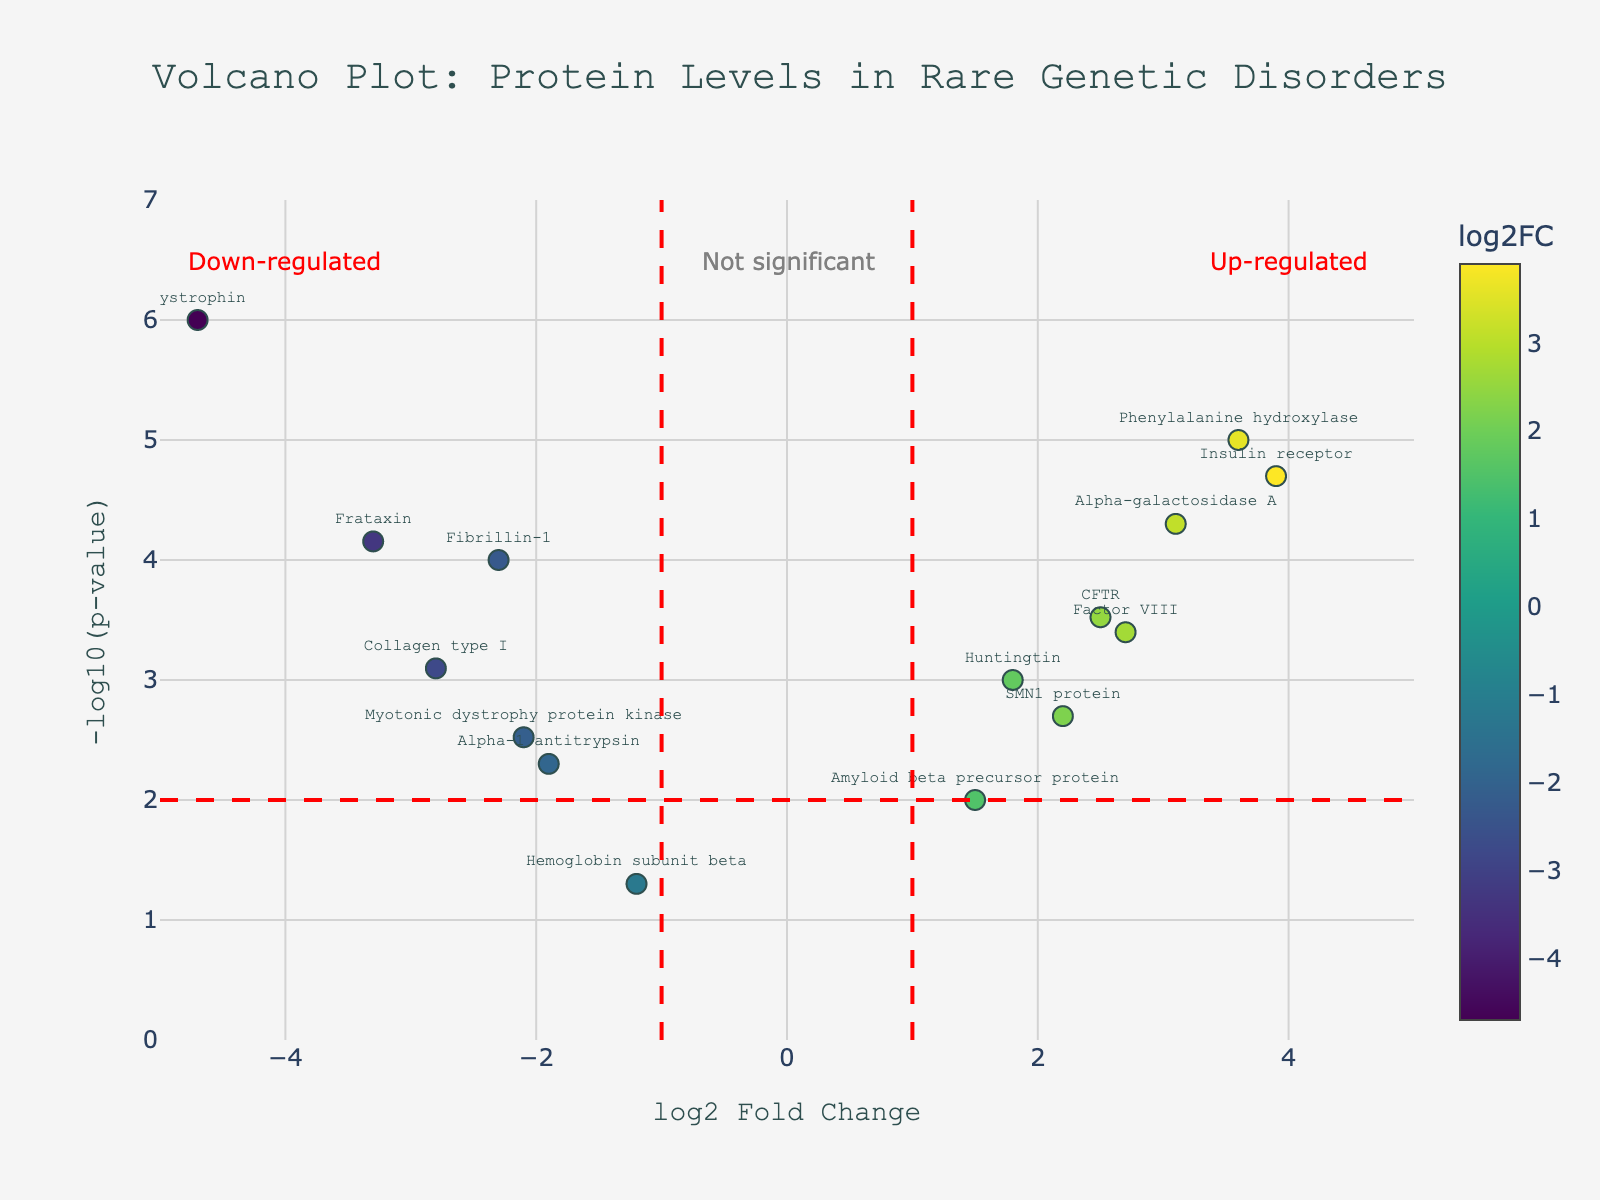What is the title of the plot? The title is usually displayed at the top of the figure. We can see the title printed clearly, aligned centrally.
Answer: Volcano Plot: Protein Levels in Rare Genetic Disorders What does the X-axis represent? The X-axis title is indicated below the horizontal axis. It specifies what is being measured or plotted on this axis.
Answer: log2 Fold Change What does the Y-axis represent? The Y-axis title is indicated beside the vertical axis. It specifies what is being measured or plotted on this axis.
Answer: -log10(p-value) How many proteins are up-regulated with significant values in patients? Proteins that are up-regulated have positive log2 Fold Change values and exceed the significance threshold line of -log10(p-value) > 2. Count these points on the plot.
Answer: 5 Which protein has the highest log2 Fold Change? This can be determined by looking for the protein with the highest value on the X-axis.
Answer: Insulin receptor Which protein is the most down-regulated? Look for the protein with the lowest value on the X-axis.
Answer: Dystrophin What is the p-value significance threshold indicated on the plot? The significance threshold line is marked by the horizontal red line on the plot. This represents -log10(p-value) = 2, corresponding to a p-value of 0.01.
Answer: 0.01 Which proteins are considered not significant? Proteins with -log10(p-value) less than or equal to 2 fall below the significance threshold. Identify these from the plot.
Answer: Hemoglobin subunit beta, Amyloid beta precursor protein, Alpha-1 antitrypsin, Myotonic dystrophy protein kinase What color scale is used to represent log2 Fold Change? The color scale depicted on the right side of the plot changes as per the log2 Fold Change values of the proteins.
Answer: Viridis Compare the log2 Fold Changes of CFTR and Dystrophin. Which one is higher? Locate the log2 Fold Change (X-axis value) for CFTR and Dystrophin and compare them. CFTR has a value of 2.5 and Dystrophin has -4.7.
Answer: CFTR 